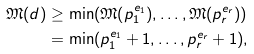Convert formula to latex. <formula><loc_0><loc_0><loc_500><loc_500>\mathfrak { M } ( d ) & \geq \min ( \mathfrak { M } ( p _ { 1 } ^ { e _ { 1 } } ) , \dots , \mathfrak { M } ( p _ { r } ^ { e _ { r } } ) ) \\ & = \min ( p _ { 1 } ^ { e _ { 1 } } + 1 , \dots , p _ { r } ^ { e _ { r } } + 1 ) ,</formula> 